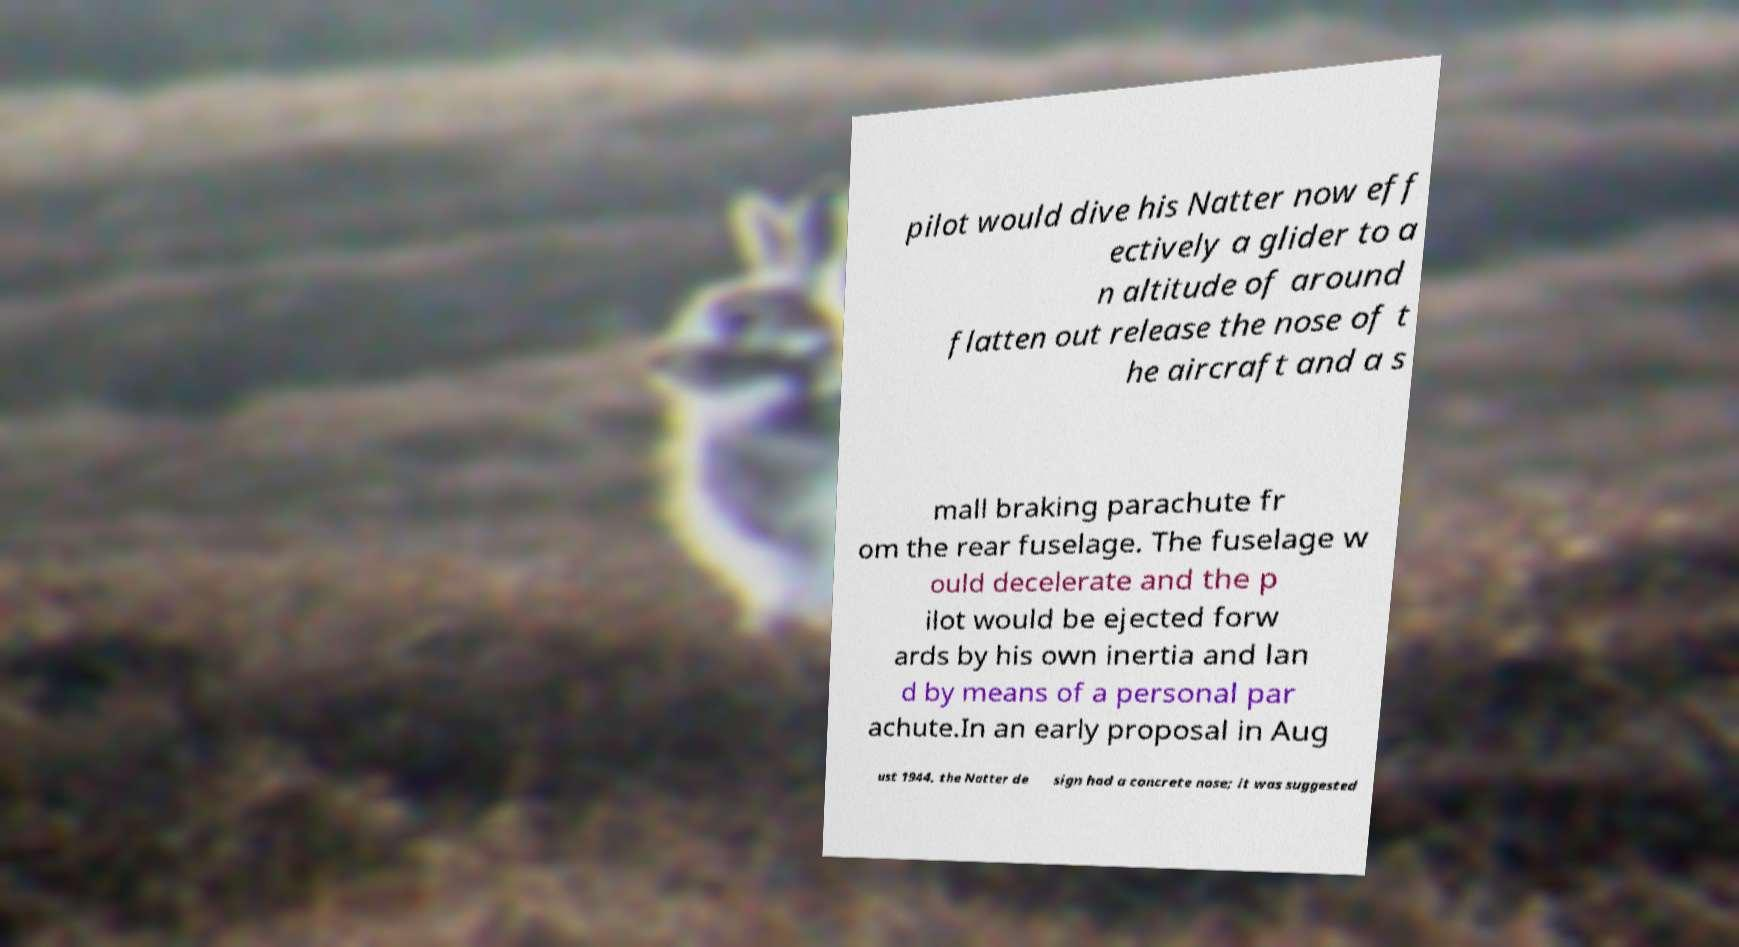Can you accurately transcribe the text from the provided image for me? pilot would dive his Natter now eff ectively a glider to a n altitude of around flatten out release the nose of t he aircraft and a s mall braking parachute fr om the rear fuselage. The fuselage w ould decelerate and the p ilot would be ejected forw ards by his own inertia and lan d by means of a personal par achute.In an early proposal in Aug ust 1944, the Natter de sign had a concrete nose; it was suggested 